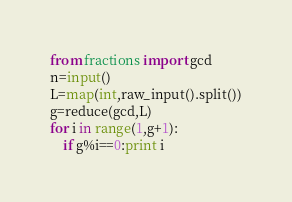<code> <loc_0><loc_0><loc_500><loc_500><_Python_>from fractions import gcd
n=input()
L=map(int,raw_input().split())
g=reduce(gcd,L)
for i in range(1,g+1):
    if g%i==0:print i</code> 